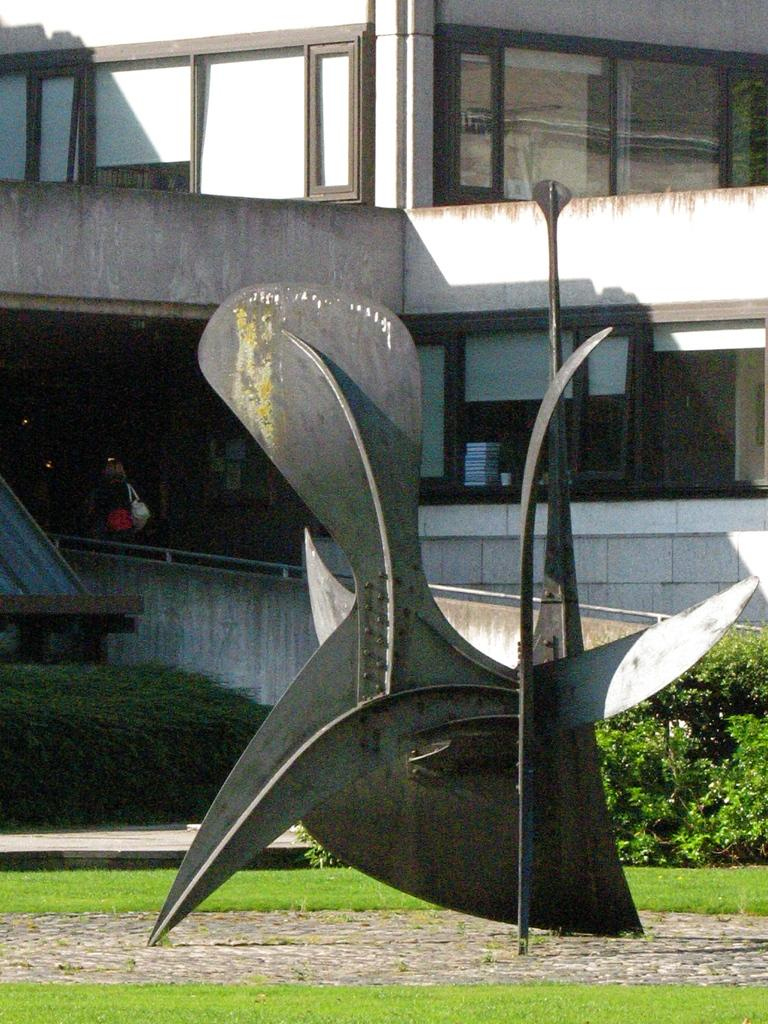What is the main subject in the middle of the image? There is an architecture in the middle of the image. What type of landscape is visible at the bottom of the image? There is a grassland at the bottom of the image. What can be seen in the background of the image? There are plants, at least one building, women, windows, and glass visible in the background of the image. What type of texture can be seen on the cherry in the image? There is no cherry present in the image, so it is not possible to determine its texture. 